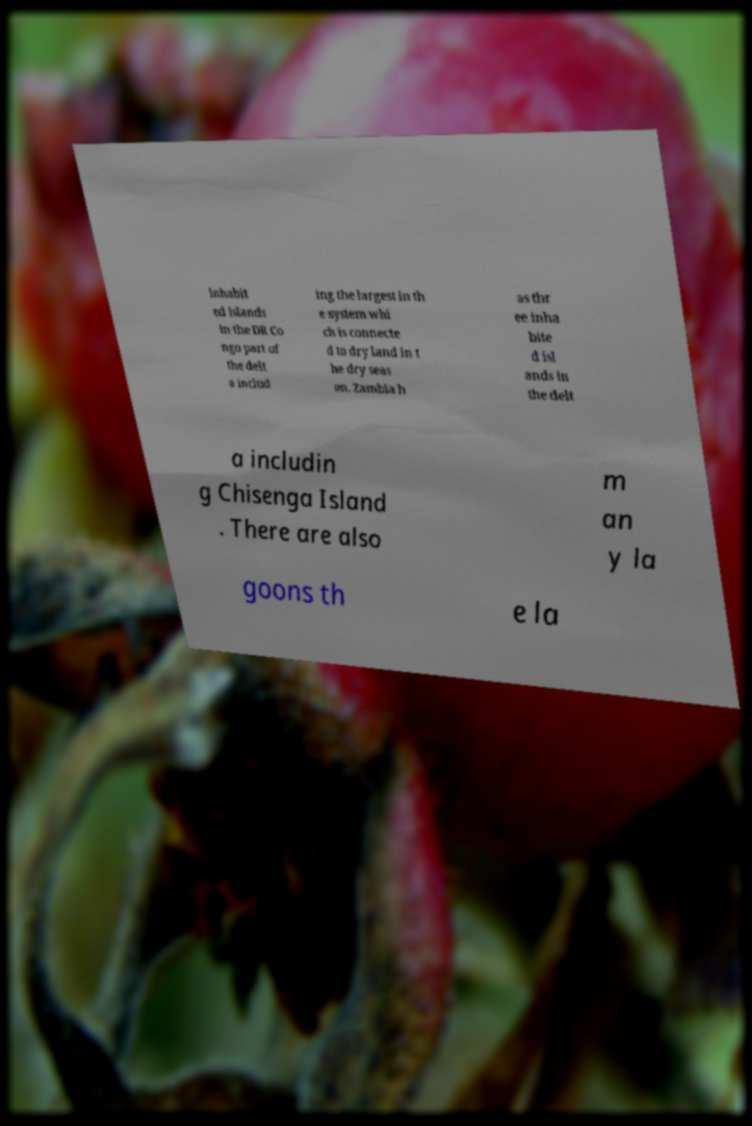Could you assist in decoding the text presented in this image and type it out clearly? inhabit ed islands in the DR Co ngo part of the delt a includ ing the largest in th e system whi ch is connecte d to dry land in t he dry seas on. Zambia h as thr ee inha bite d isl ands in the delt a includin g Chisenga Island . There are also m an y la goons th e la 